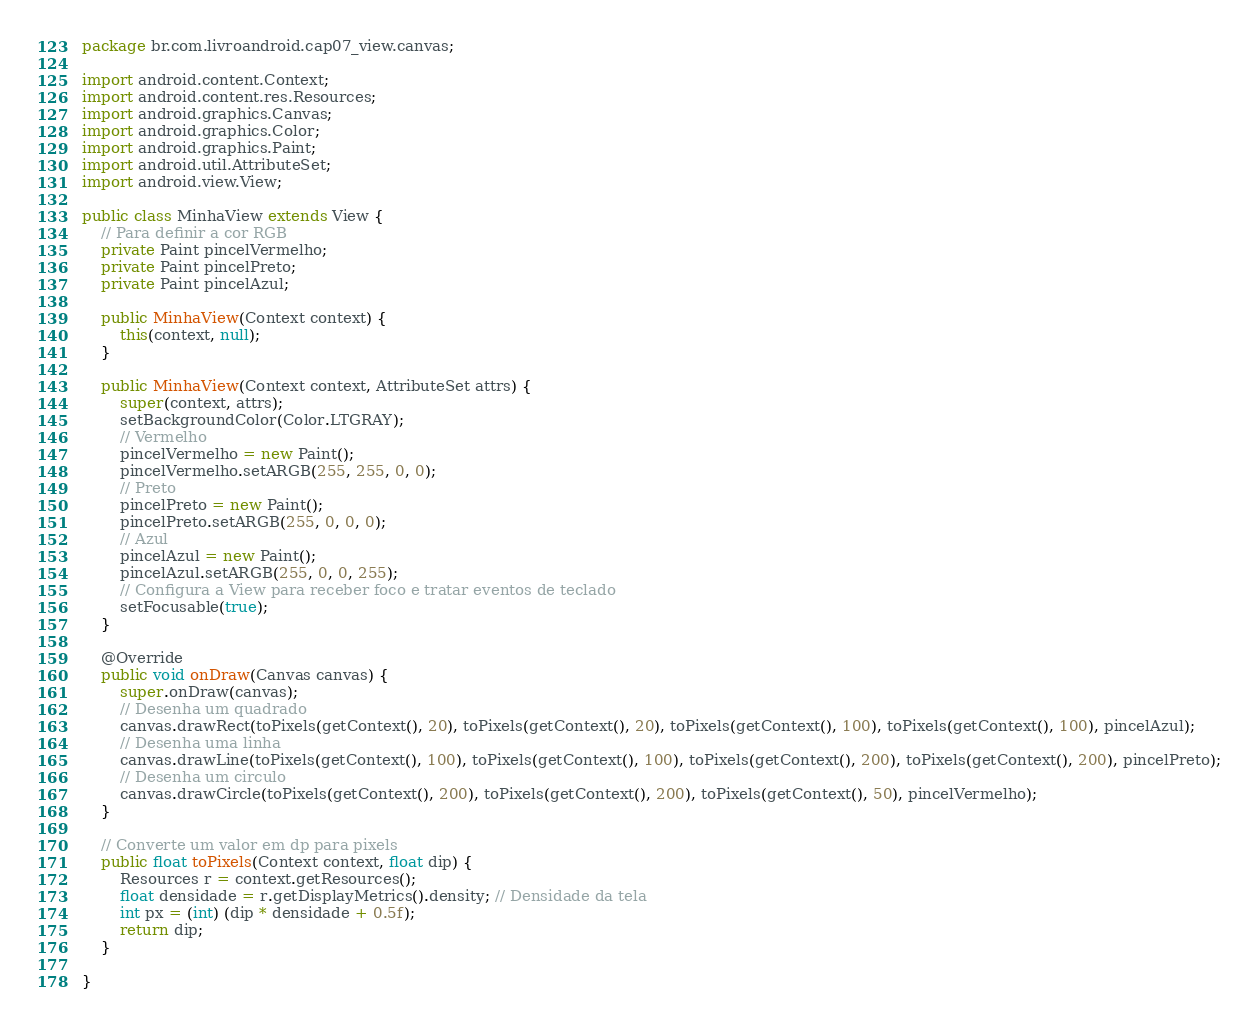Convert code to text. <code><loc_0><loc_0><loc_500><loc_500><_Java_>package br.com.livroandroid.cap07_view.canvas;

import android.content.Context;
import android.content.res.Resources;
import android.graphics.Canvas;
import android.graphics.Color;
import android.graphics.Paint;
import android.util.AttributeSet;
import android.view.View;

public class MinhaView extends View {
    // Para definir a cor RGB
    private Paint pincelVermelho;
    private Paint pincelPreto;
    private Paint pincelAzul;

    public MinhaView(Context context) {
        this(context, null);
    }

    public MinhaView(Context context, AttributeSet attrs) {
        super(context, attrs);
        setBackgroundColor(Color.LTGRAY);
        // Vermelho
        pincelVermelho = new Paint();
        pincelVermelho.setARGB(255, 255, 0, 0);
        // Preto
        pincelPreto = new Paint();
        pincelPreto.setARGB(255, 0, 0, 0);
        // Azul
        pincelAzul = new Paint();
        pincelAzul.setARGB(255, 0, 0, 255);
        // Configura a View para receber foco e tratar eventos de teclado
        setFocusable(true);
    }

    @Override
    public void onDraw(Canvas canvas) {
        super.onDraw(canvas);
        // Desenha um quadrado
        canvas.drawRect(toPixels(getContext(), 20), toPixels(getContext(), 20), toPixels(getContext(), 100), toPixels(getContext(), 100), pincelAzul);
        // Desenha uma linha
        canvas.drawLine(toPixels(getContext(), 100), toPixels(getContext(), 100), toPixels(getContext(), 200), toPixels(getContext(), 200), pincelPreto);
        // Desenha um circulo
        canvas.drawCircle(toPixels(getContext(), 200), toPixels(getContext(), 200), toPixels(getContext(), 50), pincelVermelho);
    }

    // Converte um valor em dp para pixels
    public float toPixels(Context context, float dip) {
        Resources r = context.getResources();
        float densidade = r.getDisplayMetrics().density; // Densidade da tela
        int px = (int) (dip * densidade + 0.5f);
        return dip;
    }

}
</code> 